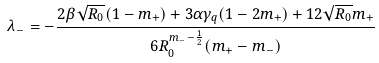<formula> <loc_0><loc_0><loc_500><loc_500>\lambda _ { - } = - \frac { 2 \beta \sqrt { R _ { 0 } } ( 1 - m _ { + } ) + 3 \alpha \gamma _ { q } ( 1 - 2 m _ { + } ) + 1 2 \sqrt { R _ { 0 } } m _ { + } } { 6 R _ { 0 } ^ { m _ { - } - \frac { 1 } { 2 } } ( m _ { + } - m _ { - } ) }</formula> 